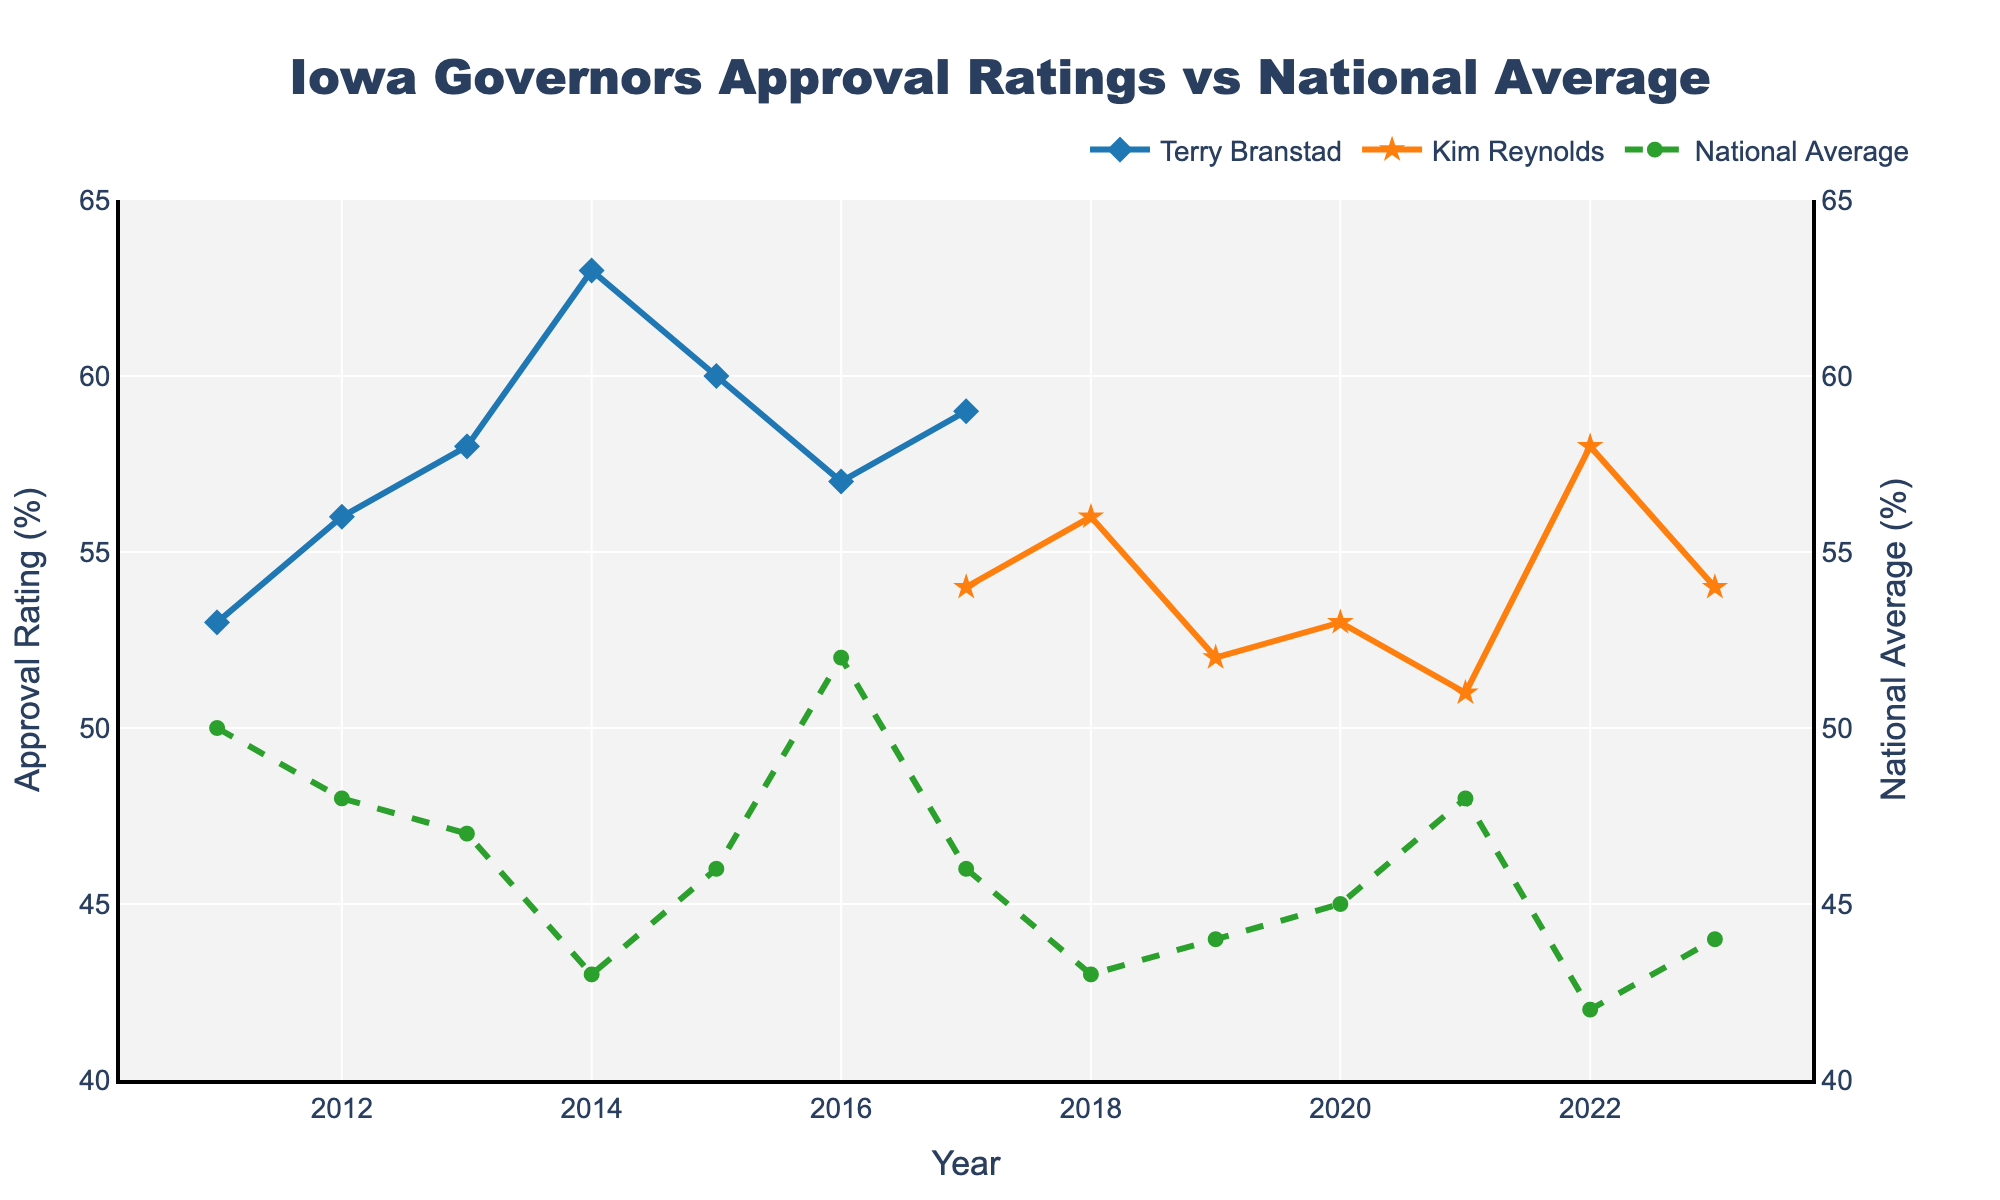What is the approval rating of Terry Branstad in 2011? According to the figure, Terry Branstad's approval rating in the year 2011 is represented by a data point on the blue line. This data point shows an approval rating of 53%.
Answer: 53% Compare the approval ratings of Kim Reynolds and the National Average in 2022. By looking at the orange and green lines associated with Kim Reynolds and the National Average respectively, the approval rating for Kim Reynolds in 2022 is 58%, while the National Average is 42%. This indicates that Kim Reynolds' approval rating is higher than the National Average in 2022.
Answer: Kim Reynolds: 58%, National Average: 42% What is the range of the National Average approval rating over the given years? Observing the green dashed line, the minimum National Average approval rating is 42% (in 2022), and the maximum is 52% (in 2016). The range is calculated as the difference between the maximum and the minimum values: 52% - 42% = 10%.
Answer: 10% How does Terry Branstad's approval rating in his last year (2016) compare to his approval rating in his first year (2011)? From the blue line, Terry Branstad's approval rating in 2011 is 53%, and in 2016 (his last year) it is 57%. This shows an increase of 4%.
Answer: Increased by 4% Identify the year with the highest approval rating for any Iowa governor and provide the year and the governor's name. Observing the highest points on both the blue and orange lines, the peak occurs in 2014 for Terry Branstad with an approval rating of 63%.
Answer: 2014, Terry Branstad What trend can be observed about Kim Reynolds' approval ratings from 2018 to 2023? The orange line, representing Kim Reynolds, shows fluctuations but generally remains within the range of 51% to 58%. There is no significant upward or downward trend visible.
Answer: Relatively stable with minor fluctuations For how many years did Terry Branstad's approval rating exceed the National Average? By comparing the blue and green lines, Terry Branstad's approval rating is above the National Average in the years 2011, 2012, 2013, 2014, and 2017. This accounts for 5 years in total.
Answer: 5 years Which year did Kim Reynolds have the lowest approval rating, and what was it? The lowest point on the orange line for Kim Reynolds is in 2021, with an approval rating of 51%.
Answer: 2021, 51% How does the approval rating variability of Kim Reynolds compare to the National Average from 2017 to 2023? Between 2017 and 2023, Kim Reynolds' approval rating fluctuates between 51% and 58% (a range of 7%). The National Average fluctuates between 42% and 48% (a range of 6%). Thus, Kim Reynolds has slightly greater variability.
Answer: Kim Reynolds: 7%, National Average: 6% Calculate the average approval rating for Terry Branstad over his term. Terry Branstad's approval ratings from 2011 to 2016 are 53%, 56%, 58%, 63%, 60%, and 57%. Adding these gives 347%. Divided by the number of years (6), the average approval rating is approximately 57.8%.
Answer: 57.8% 